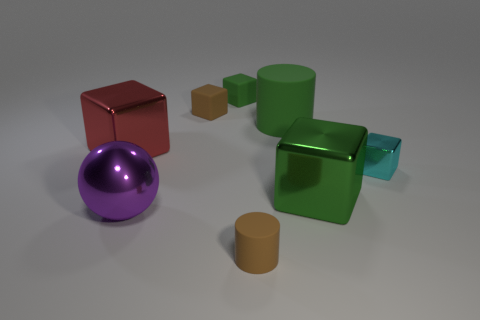Do the rubber object that is behind the brown matte block and the big metal thing that is behind the tiny cyan object have the same shape?
Offer a very short reply. Yes. Are there any other things that are the same shape as the red shiny object?
Offer a terse response. Yes. The purple thing that is made of the same material as the red cube is what shape?
Make the answer very short. Sphere. Is the number of tiny metal blocks that are in front of the purple ball the same as the number of big gray metallic balls?
Make the answer very short. Yes. Are the cylinder that is in front of the big shiny ball and the green object that is behind the brown rubber cube made of the same material?
Provide a succinct answer. Yes. What is the shape of the green rubber object on the left side of the small brown rubber thing in front of the large red cube?
Your answer should be very brief. Cube. There is a small cube that is the same material as the large green block; what is its color?
Your response must be concise. Cyan. Does the sphere have the same color as the big rubber thing?
Keep it short and to the point. No. There is a green matte thing that is the same size as the cyan metal object; what is its shape?
Provide a succinct answer. Cube. How big is the red object?
Keep it short and to the point. Large. 